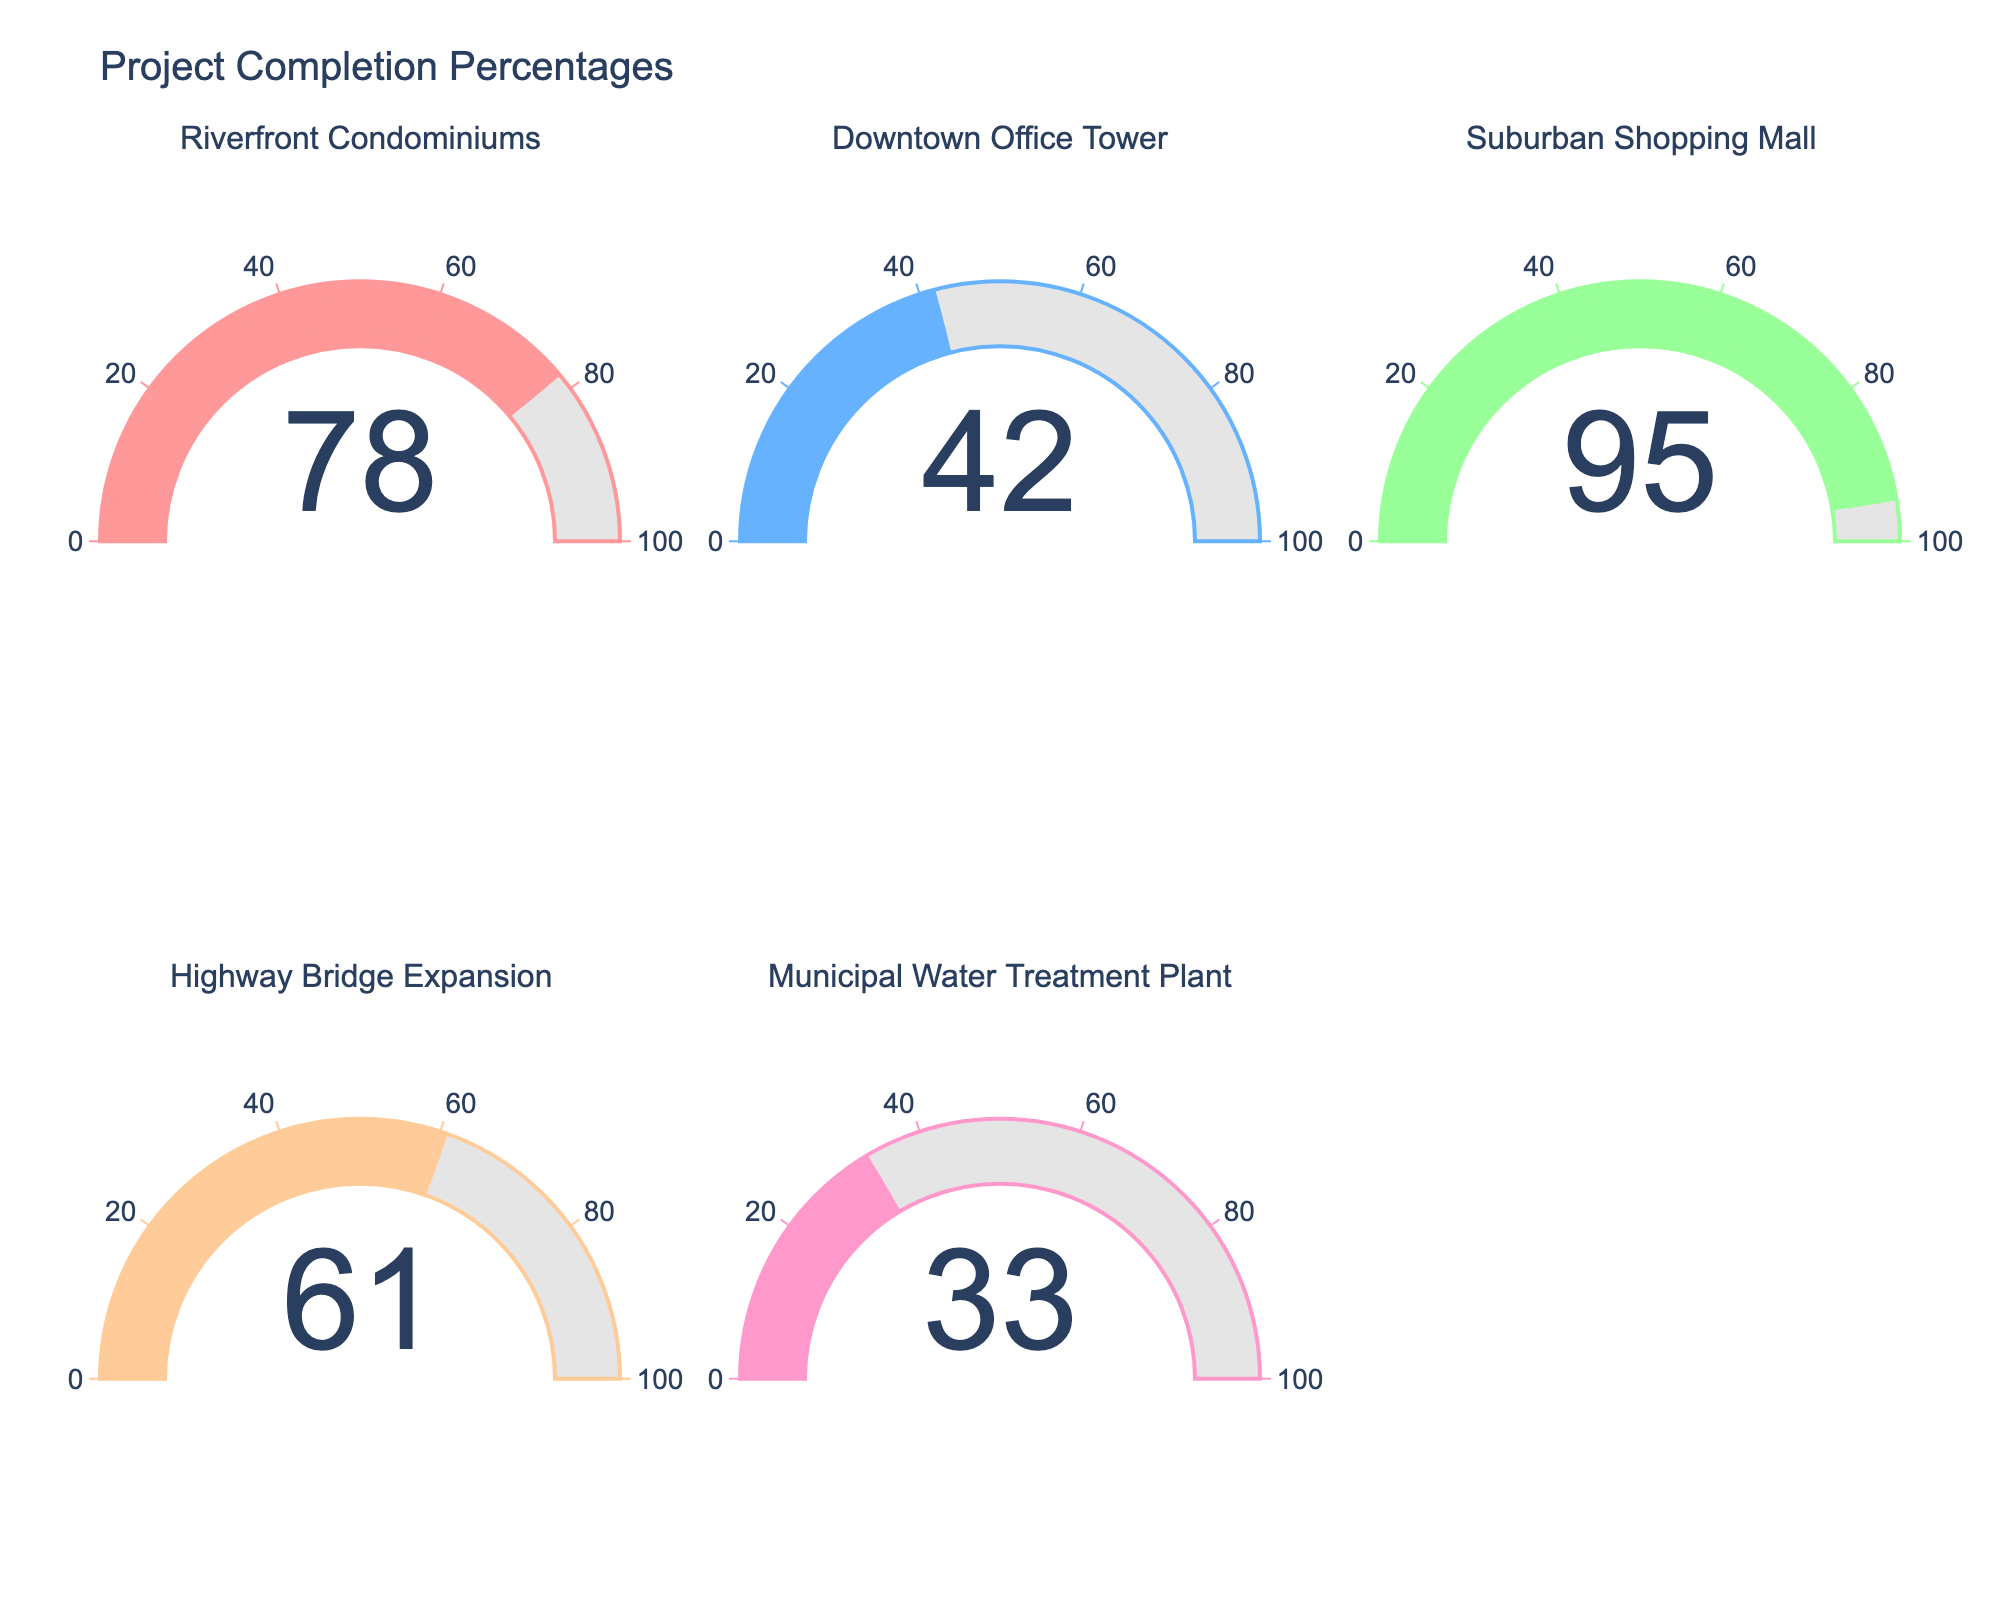Which project has the highest completion percentage? The gauge chart shows the project completion percentages for several projects. The Suburban Shopping Mall has a value of 95, which is the highest.
Answer: Suburban Shopping Mall Which project shows the lowest completion percentage? The gauge chart for the Municipal Water Treatment Plant shows a completion percentage of 33, which is the lowest among all the projects listed.
Answer: Municipal Water Treatment Plant What is the difference in completion percentage between the Downtown Office Tower and the Highway Bridge Expansion? The Downtown Office Tower has a completion percentage of 42, and the Highway Bridge Expansion has 61. The difference is 61 - 42 = 19.
Answer: 19 What is the average completion percentage of all the projects? Adding up the completion percentages (78 + 42 + 95 + 61 + 33) equals 309. Dividing by 5 (the number of projects) results in an average of 309 / 5 = 61.8.
Answer: 61.8 Between the Riverfront Condominiums and the Downtown Office Tower, which project is closer to completion? The Riverfront Condominiums has a completion percentage of 78, while the Downtown Office Tower has a percentage of 42. Since 78 is greater than 42, the Riverfront Condominiums is closer to completion.
Answer: Riverfront Condominiums How many projects have a completion percentage greater than 50%? Checking each project's completion percentage, Riverfront Condominiums has 78, Suburban Shopping Mall has 95, and Highway Bridge Expansion has 61, all of which are greater than 50%. That's 3 projects.
Answer: 3 If you were to prioritize projects based on completion percentage, which project would be the second priority? The Suburban Shopping Mall is the highest with 95 and therefore the first priority. The Riverfront Condominiums is next with 78, making it the second priority.
Answer: Riverfront Condominiums What is the total completion percentage sum of all the projects combined? Summing the percentages of all projects: 78 (Riverfront Condominiums) + 42 (Downtown Office Tower) + 95 (Suburban Shopping Mall) + 61 (Highway Bridge Expansion) + 33 (Municipal Water Treatment Plant) is 309.
Answer: 309 Which two projects together have a combined completion percentage of more than 100%? Checking combinations, Riverfront Condominiums (78) + Highway Bridge Expansion (61) equals 139, and Riverfront Condominiums (78) + Suburban Shopping Mall (95) equals 173. Both combinations exceed 100%.
Answer: Riverfront Condominiums and Highway Bridge Expansion Are there any projects with a completion percentage below 40%? The Municipal Water Treatment Plant, with a completion percentage of 33, is the only project below 40%.
Answer: Yes 